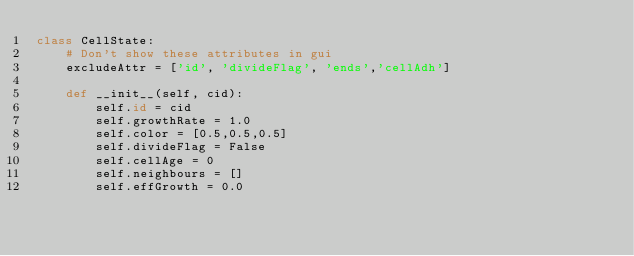<code> <loc_0><loc_0><loc_500><loc_500><_Python_>class CellState:
    # Don't show these attributes in gui
    excludeAttr = ['id', 'divideFlag', 'ends','cellAdh']

    def __init__(self, cid):
        self.id = cid
        self.growthRate = 1.0
        self.color = [0.5,0.5,0.5]
        self.divideFlag = False
        self.cellAge = 0
        self.neighbours = []
        self.effGrowth = 0.0
</code> 